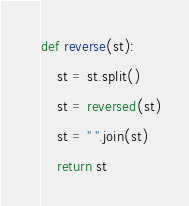<code> <loc_0><loc_0><loc_500><loc_500><_Python_>def reverse(st):
    st = st.split()
    st = reversed(st)
    st = " ".join(st)
    return st
</code> 